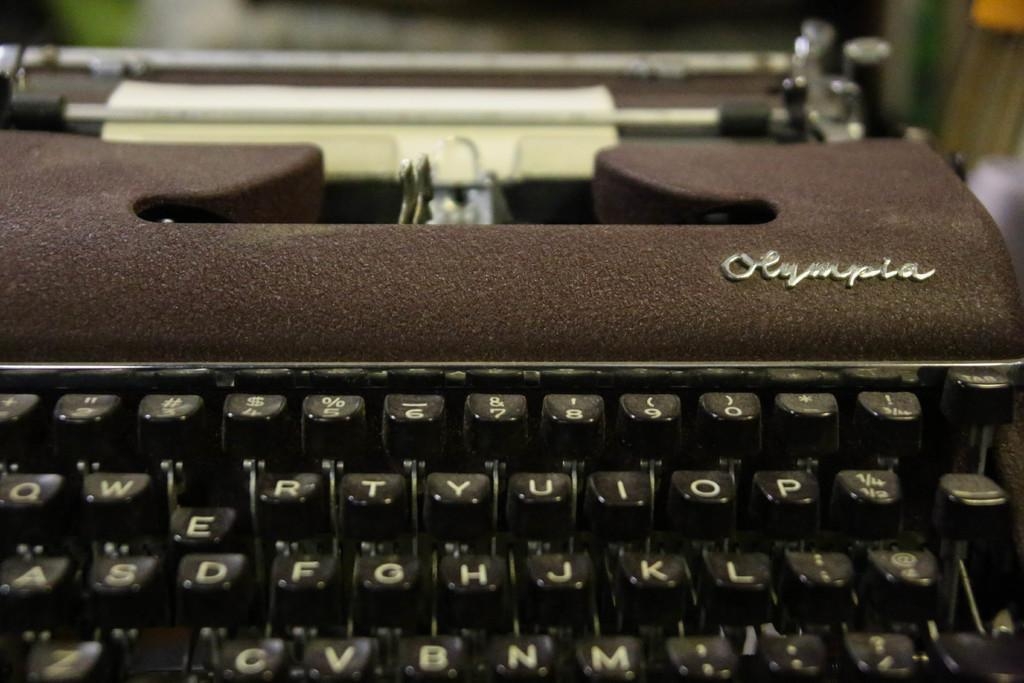<image>
Render a clear and concise summary of the photo. An old fashion black typewriter from Olympia with square keys that also has a piece of paper in it. 